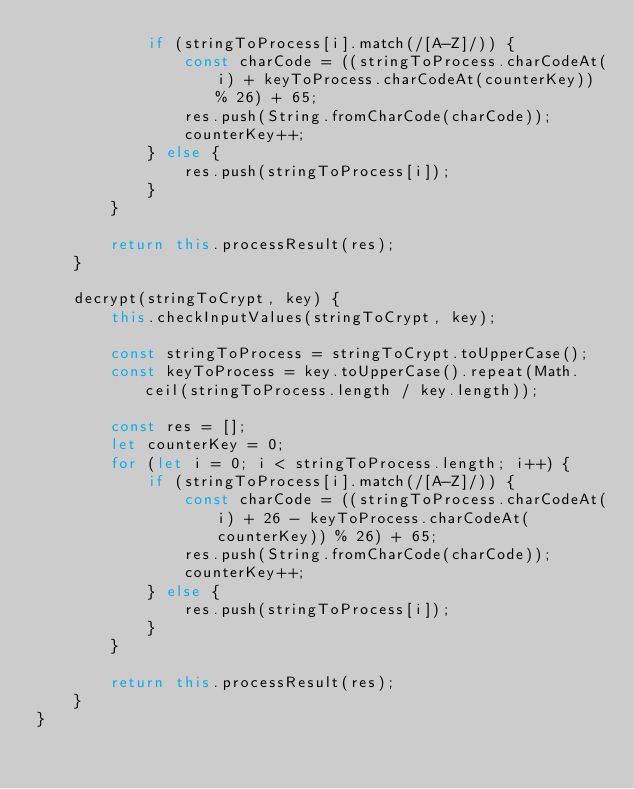<code> <loc_0><loc_0><loc_500><loc_500><_JavaScript_>            if (stringToProcess[i].match(/[A-Z]/)) {
                const charCode = ((stringToProcess.charCodeAt(i) + keyToProcess.charCodeAt(counterKey)) % 26) + 65;
                res.push(String.fromCharCode(charCode));
                counterKey++;
            } else {
                res.push(stringToProcess[i]);
            }
        }

        return this.processResult(res);
    }

    decrypt(stringToCrypt, key) {
        this.checkInputValues(stringToCrypt, key);

        const stringToProcess = stringToCrypt.toUpperCase();
        const keyToProcess = key.toUpperCase().repeat(Math.ceil(stringToProcess.length / key.length));

        const res = [];
        let counterKey = 0;
        for (let i = 0; i < stringToProcess.length; i++) {
            if (stringToProcess[i].match(/[A-Z]/)) {
                const charCode = ((stringToProcess.charCodeAt(i) + 26 - keyToProcess.charCodeAt(counterKey)) % 26) + 65;
                res.push(String.fromCharCode(charCode));
                counterKey++;
            } else {
                res.push(stringToProcess[i]);
            }
        }

        return this.processResult(res);
    }
}
</code> 